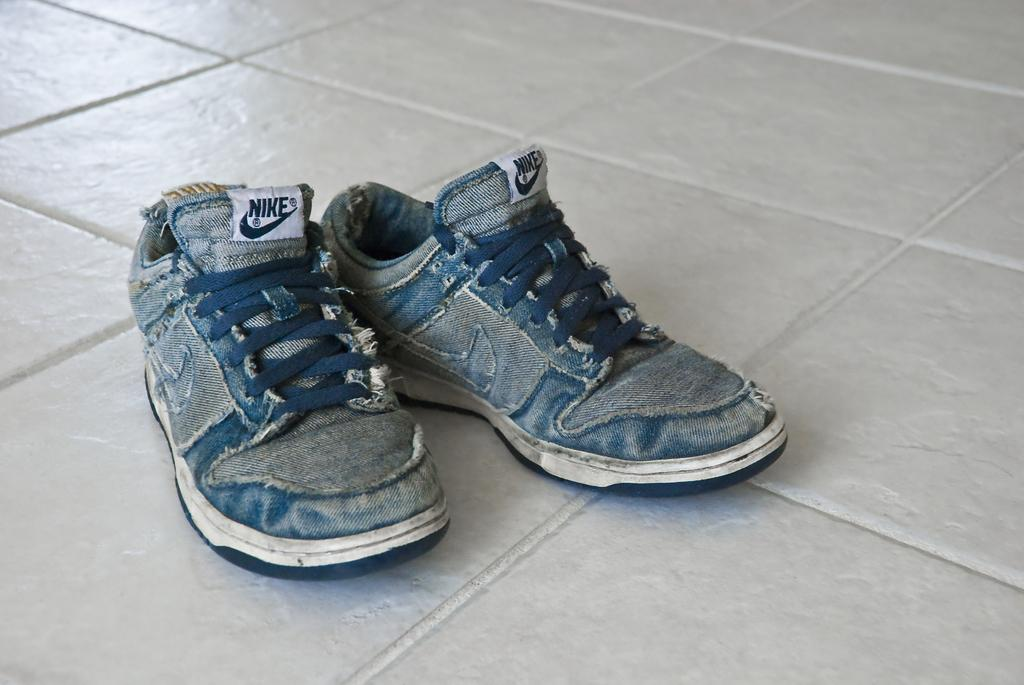What objects are on the ground in the image? There are shoes on the ground. Can you describe the shoes in the image? The shoes are placed on the ground. What might someone do with the shoes in the image? Someone might put on or take off the shoes. What type of pen can be seen in the image? There is no pen present in the image; it only features shoes on the ground. 